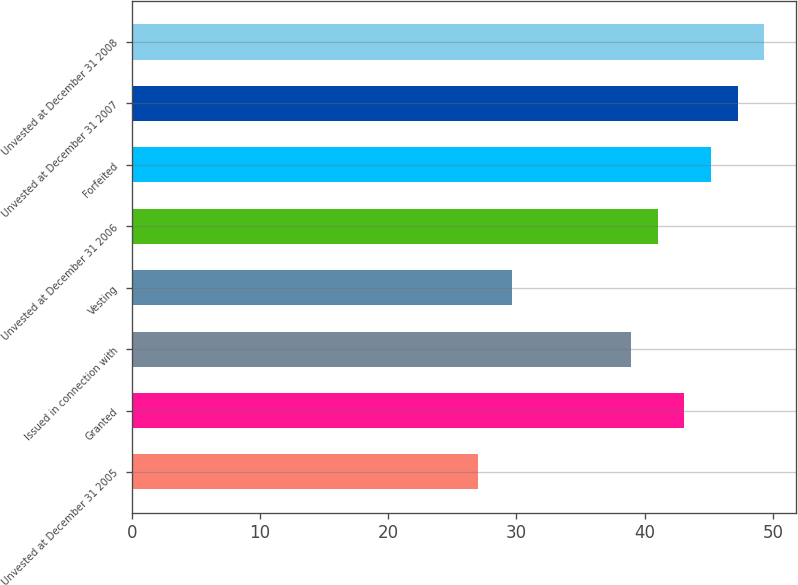Convert chart. <chart><loc_0><loc_0><loc_500><loc_500><bar_chart><fcel>Unvested at December 31 2005<fcel>Granted<fcel>Issued in connection with<fcel>Vesting<fcel>Unvested at December 31 2006<fcel>Forfeited<fcel>Unvested at December 31 2007<fcel>Unvested at December 31 2008<nl><fcel>27.03<fcel>43.09<fcel>38.93<fcel>29.62<fcel>41.01<fcel>45.17<fcel>47.25<fcel>49.33<nl></chart> 